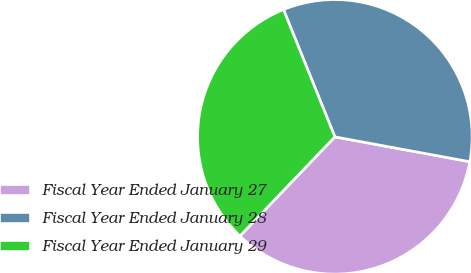<chart> <loc_0><loc_0><loc_500><loc_500><pie_chart><fcel>Fiscal Year Ended January 27<fcel>Fiscal Year Ended January 28<fcel>Fiscal Year Ended January 29<nl><fcel>34.25%<fcel>34.01%<fcel>31.74%<nl></chart> 